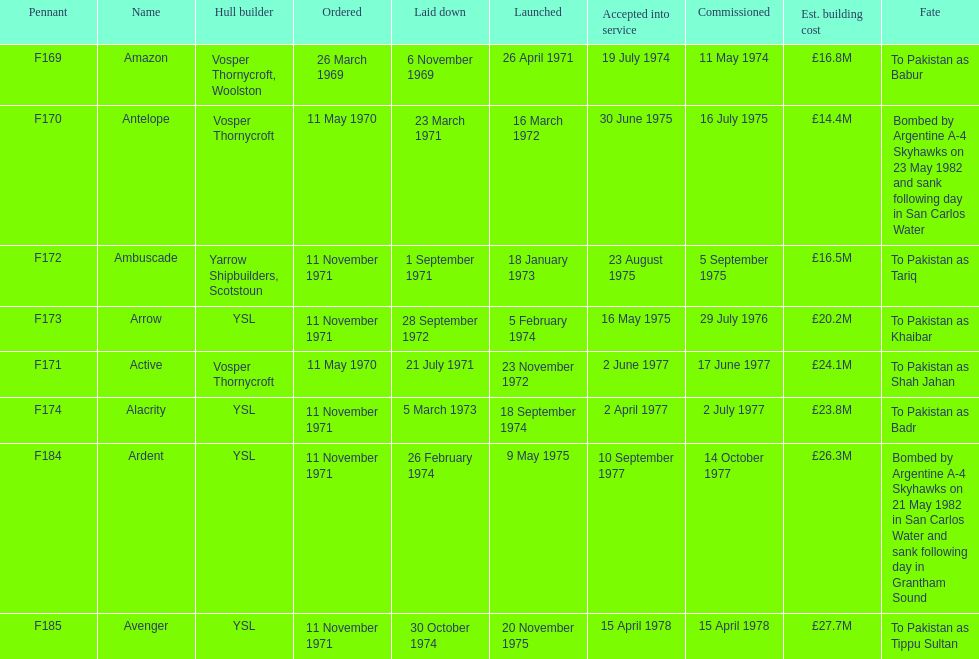How many ships were built after ardent? 1. Could you help me parse every detail presented in this table? {'header': ['Pennant', 'Name', 'Hull builder', 'Ordered', 'Laid down', 'Launched', 'Accepted into service', 'Commissioned', 'Est. building cost', 'Fate'], 'rows': [['F169', 'Amazon', 'Vosper Thornycroft, Woolston', '26 March 1969', '6 November 1969', '26 April 1971', '19 July 1974', '11 May 1974', '£16.8M', 'To Pakistan as Babur'], ['F170', 'Antelope', 'Vosper Thornycroft', '11 May 1970', '23 March 1971', '16 March 1972', '30 June 1975', '16 July 1975', '£14.4M', 'Bombed by Argentine A-4 Skyhawks on 23 May 1982 and sank following day in San Carlos Water'], ['F172', 'Ambuscade', 'Yarrow Shipbuilders, Scotstoun', '11 November 1971', '1 September 1971', '18 January 1973', '23 August 1975', '5 September 1975', '£16.5M', 'To Pakistan as Tariq'], ['F173', 'Arrow', 'YSL', '11 November 1971', '28 September 1972', '5 February 1974', '16 May 1975', '29 July 1976', '£20.2M', 'To Pakistan as Khaibar'], ['F171', 'Active', 'Vosper Thornycroft', '11 May 1970', '21 July 1971', '23 November 1972', '2 June 1977', '17 June 1977', '£24.1M', 'To Pakistan as Shah Jahan'], ['F174', 'Alacrity', 'YSL', '11 November 1971', '5 March 1973', '18 September 1974', '2 April 1977', '2 July 1977', '£23.8M', 'To Pakistan as Badr'], ['F184', 'Ardent', 'YSL', '11 November 1971', '26 February 1974', '9 May 1975', '10 September 1977', '14 October 1977', '£26.3M', 'Bombed by Argentine A-4 Skyhawks on 21 May 1982 in San Carlos Water and sank following day in Grantham Sound'], ['F185', 'Avenger', 'YSL', '11 November 1971', '30 October 1974', '20 November 1975', '15 April 1978', '15 April 1978', '£27.7M', 'To Pakistan as Tippu Sultan']]} 